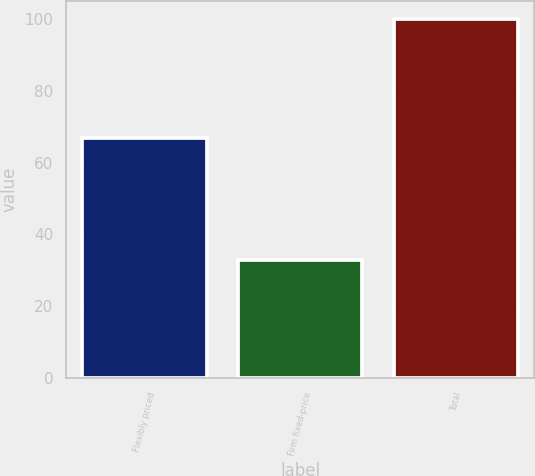Convert chart to OTSL. <chart><loc_0><loc_0><loc_500><loc_500><bar_chart><fcel>Flexibly priced<fcel>Firm fixed-price<fcel>Total<nl><fcel>67<fcel>33<fcel>100<nl></chart> 